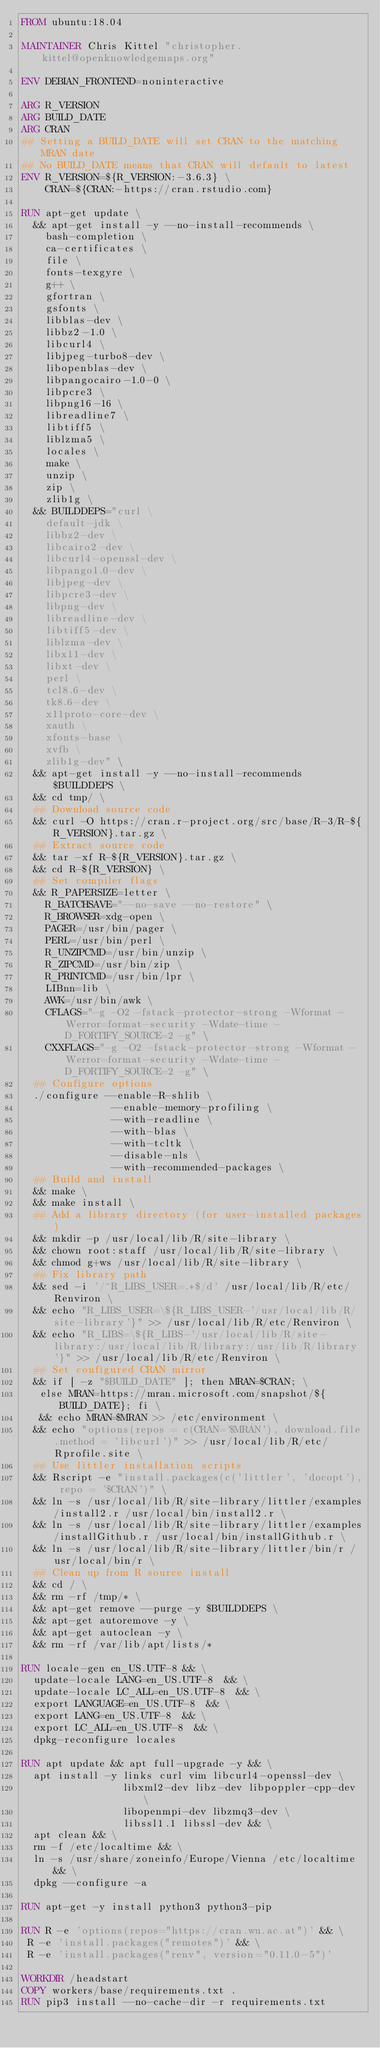Convert code to text. <code><loc_0><loc_0><loc_500><loc_500><_Dockerfile_>FROM ubuntu:18.04

MAINTAINER Chris Kittel "christopher.kittel@openknowledgemaps.org"

ENV DEBIAN_FRONTEND=noninteractive

ARG R_VERSION
ARG BUILD_DATE
ARG CRAN
## Setting a BUILD_DATE will set CRAN to the matching MRAN date
## No BUILD_DATE means that CRAN will default to latest
ENV R_VERSION=${R_VERSION:-3.6.3} \
    CRAN=${CRAN:-https://cran.rstudio.com}

RUN apt-get update \
  && apt-get install -y --no-install-recommends \
    bash-completion \
    ca-certificates \
    file \
    fonts-texgyre \
    g++ \
    gfortran \
    gsfonts \
    libblas-dev \
    libbz2-1.0 \
    libcurl4 \
    libjpeg-turbo8-dev \
    libopenblas-dev \
    libpangocairo-1.0-0 \
    libpcre3 \
    libpng16-16 \
    libreadline7 \
    libtiff5 \
    liblzma5 \
    locales \
    make \
    unzip \
    zip \
    zlib1g \
  && BUILDDEPS="curl \
    default-jdk \
    libbz2-dev \
    libcairo2-dev \
    libcurl4-openssl-dev \
    libpango1.0-dev \
    libjpeg-dev \
    libpcre3-dev \
    libpng-dev \
    libreadline-dev \
    libtiff5-dev \
    liblzma-dev \
    libx11-dev \
    libxt-dev \
    perl \
    tcl8.6-dev \
    tk8.6-dev \
    x11proto-core-dev \
    xauth \
    xfonts-base \
    xvfb \
    zlib1g-dev" \
  && apt-get install -y --no-install-recommends $BUILDDEPS \
  && cd tmp/ \
  ## Download source code
  && curl -O https://cran.r-project.org/src/base/R-3/R-${R_VERSION}.tar.gz \
  ## Extract source code
  && tar -xf R-${R_VERSION}.tar.gz \
  && cd R-${R_VERSION} \
  ## Set compiler flags
  && R_PAPERSIZE=letter \
    R_BATCHSAVE="--no-save --no-restore" \
    R_BROWSER=xdg-open \
    PAGER=/usr/bin/pager \
    PERL=/usr/bin/perl \
    R_UNZIPCMD=/usr/bin/unzip \
    R_ZIPCMD=/usr/bin/zip \
    R_PRINTCMD=/usr/bin/lpr \
    LIBnn=lib \
    AWK=/usr/bin/awk \
    CFLAGS="-g -O2 -fstack-protector-strong -Wformat -Werror=format-security -Wdate-time -D_FORTIFY_SOURCE=2 -g" \
    CXXFLAGS="-g -O2 -fstack-protector-strong -Wformat -Werror=format-security -Wdate-time -D_FORTIFY_SOURCE=2 -g" \
  ## Configure options
  ./configure --enable-R-shlib \
               --enable-memory-profiling \
               --with-readline \
               --with-blas \
               --with-tcltk \
               --disable-nls \
               --with-recommended-packages \
  ## Build and install
  && make \
  && make install \
  ## Add a library directory (for user-installed packages)
  && mkdir -p /usr/local/lib/R/site-library \
  && chown root:staff /usr/local/lib/R/site-library \
  && chmod g+ws /usr/local/lib/R/site-library \
  ## Fix library path
  && sed -i '/^R_LIBS_USER=.*$/d' /usr/local/lib/R/etc/Renviron \
  && echo "R_LIBS_USER=\${R_LIBS_USER-'/usr/local/lib/R/site-library'}" >> /usr/local/lib/R/etc/Renviron \
  && echo "R_LIBS=\${R_LIBS-'/usr/local/lib/R/site-library:/usr/local/lib/R/library:/usr/lib/R/library'}" >> /usr/local/lib/R/etc/Renviron \
  ## Set configured CRAN mirror
  && if [ -z "$BUILD_DATE" ]; then MRAN=$CRAN; \
   else MRAN=https://mran.microsoft.com/snapshot/${BUILD_DATE}; fi \
   && echo MRAN=$MRAN >> /etc/environment \
  && echo "options(repos = c(CRAN='$MRAN'), download.file.method = 'libcurl')" >> /usr/local/lib/R/etc/Rprofile.site \
  ## Use littler installation scripts
  && Rscript -e "install.packages(c('littler', 'docopt'), repo = '$CRAN')" \
  && ln -s /usr/local/lib/R/site-library/littler/examples/install2.r /usr/local/bin/install2.r \
  && ln -s /usr/local/lib/R/site-library/littler/examples/installGithub.r /usr/local/bin/installGithub.r \
  && ln -s /usr/local/lib/R/site-library/littler/bin/r /usr/local/bin/r \
  ## Clean up from R source install
  && cd / \
  && rm -rf /tmp/* \
  && apt-get remove --purge -y $BUILDDEPS \
  && apt-get autoremove -y \
  && apt-get autoclean -y \
  && rm -rf /var/lib/apt/lists/*

RUN locale-gen en_US.UTF-8 && \
  update-locale LANG=en_US.UTF-8  && \
  update-locale LC_ALL=en_US.UTF-8  && \
  export LANGUAGE=en_US.UTF-8  && \
  export LANG=en_US.UTF-8  && \
  export LC_ALL=en_US.UTF-8  && \
  dpkg-reconfigure locales

RUN apt update && apt full-upgrade -y && \
  apt install -y links curl vim libcurl4-openssl-dev \
                 libxml2-dev libz-dev libpoppler-cpp-dev \
                 libopenmpi-dev libzmq3-dev \
                 libssl1.1 libssl-dev && \
  apt clean && \
  rm -f /etc/localtime && \
  ln -s /usr/share/zoneinfo/Europe/Vienna /etc/localtime && \
  dpkg --configure -a

RUN apt-get -y install python3 python3-pip

RUN R -e 'options(repos="https://cran.wu.ac.at")' && \
 R -e 'install.packages("remotes")' && \
 R -e 'install.packages("renv", version="0.11.0-5")'

WORKDIR /headstart
COPY workers/base/requirements.txt .
RUN pip3 install --no-cache-dir -r requirements.txt
</code> 